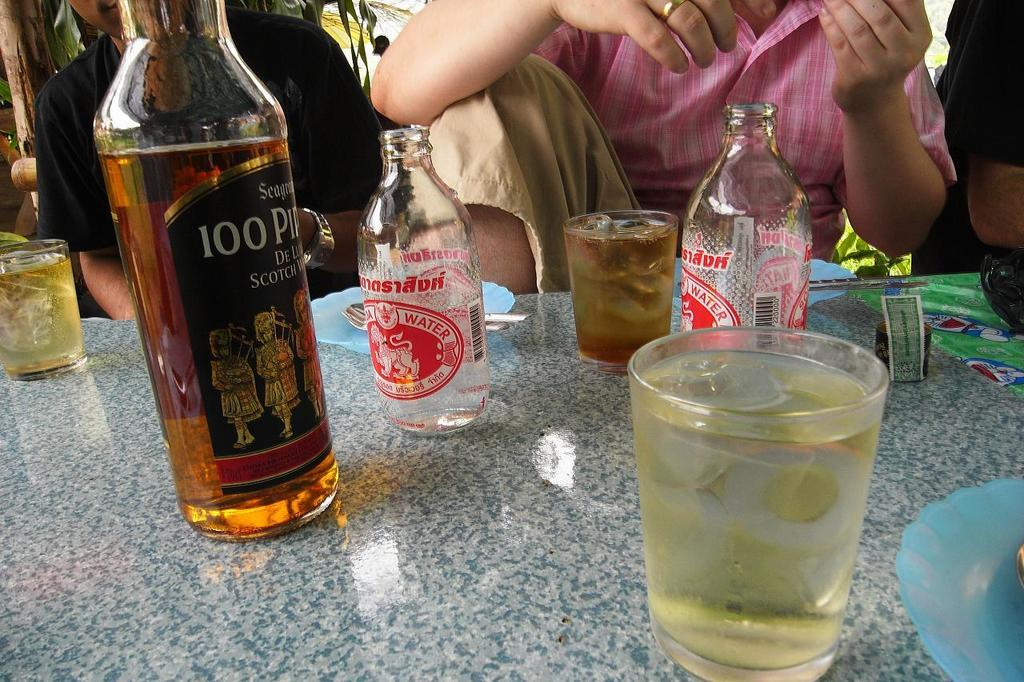<image>
Summarize the visual content of the image. the word water is on the front of an item with a red label 